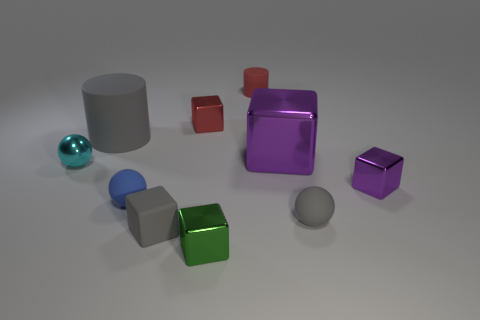Subtract all tiny blue matte spheres. How many spheres are left? 2 Subtract all gray blocks. How many blocks are left? 4 Subtract 2 cylinders. How many cylinders are left? 0 Subtract all balls. How many objects are left? 7 Add 3 small green cubes. How many small green cubes are left? 4 Add 4 big purple shiny things. How many big purple shiny things exist? 5 Subtract 1 red cylinders. How many objects are left? 9 Subtract all blue balls. Subtract all green cylinders. How many balls are left? 2 Subtract all green cylinders. How many purple blocks are left? 2 Subtract all small things. Subtract all small gray matte balls. How many objects are left? 1 